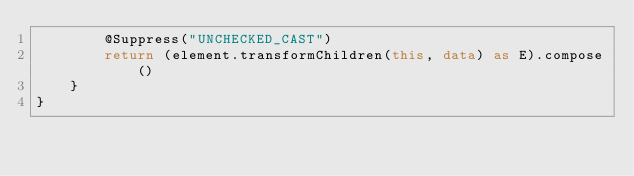<code> <loc_0><loc_0><loc_500><loc_500><_Kotlin_>        @Suppress("UNCHECKED_CAST")
        return (element.transformChildren(this, data) as E).compose()
    }
}</code> 